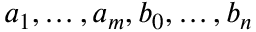<formula> <loc_0><loc_0><loc_500><loc_500>a _ { 1 } , \dots , a _ { m } , b _ { 0 } , \dots , b _ { n }</formula> 